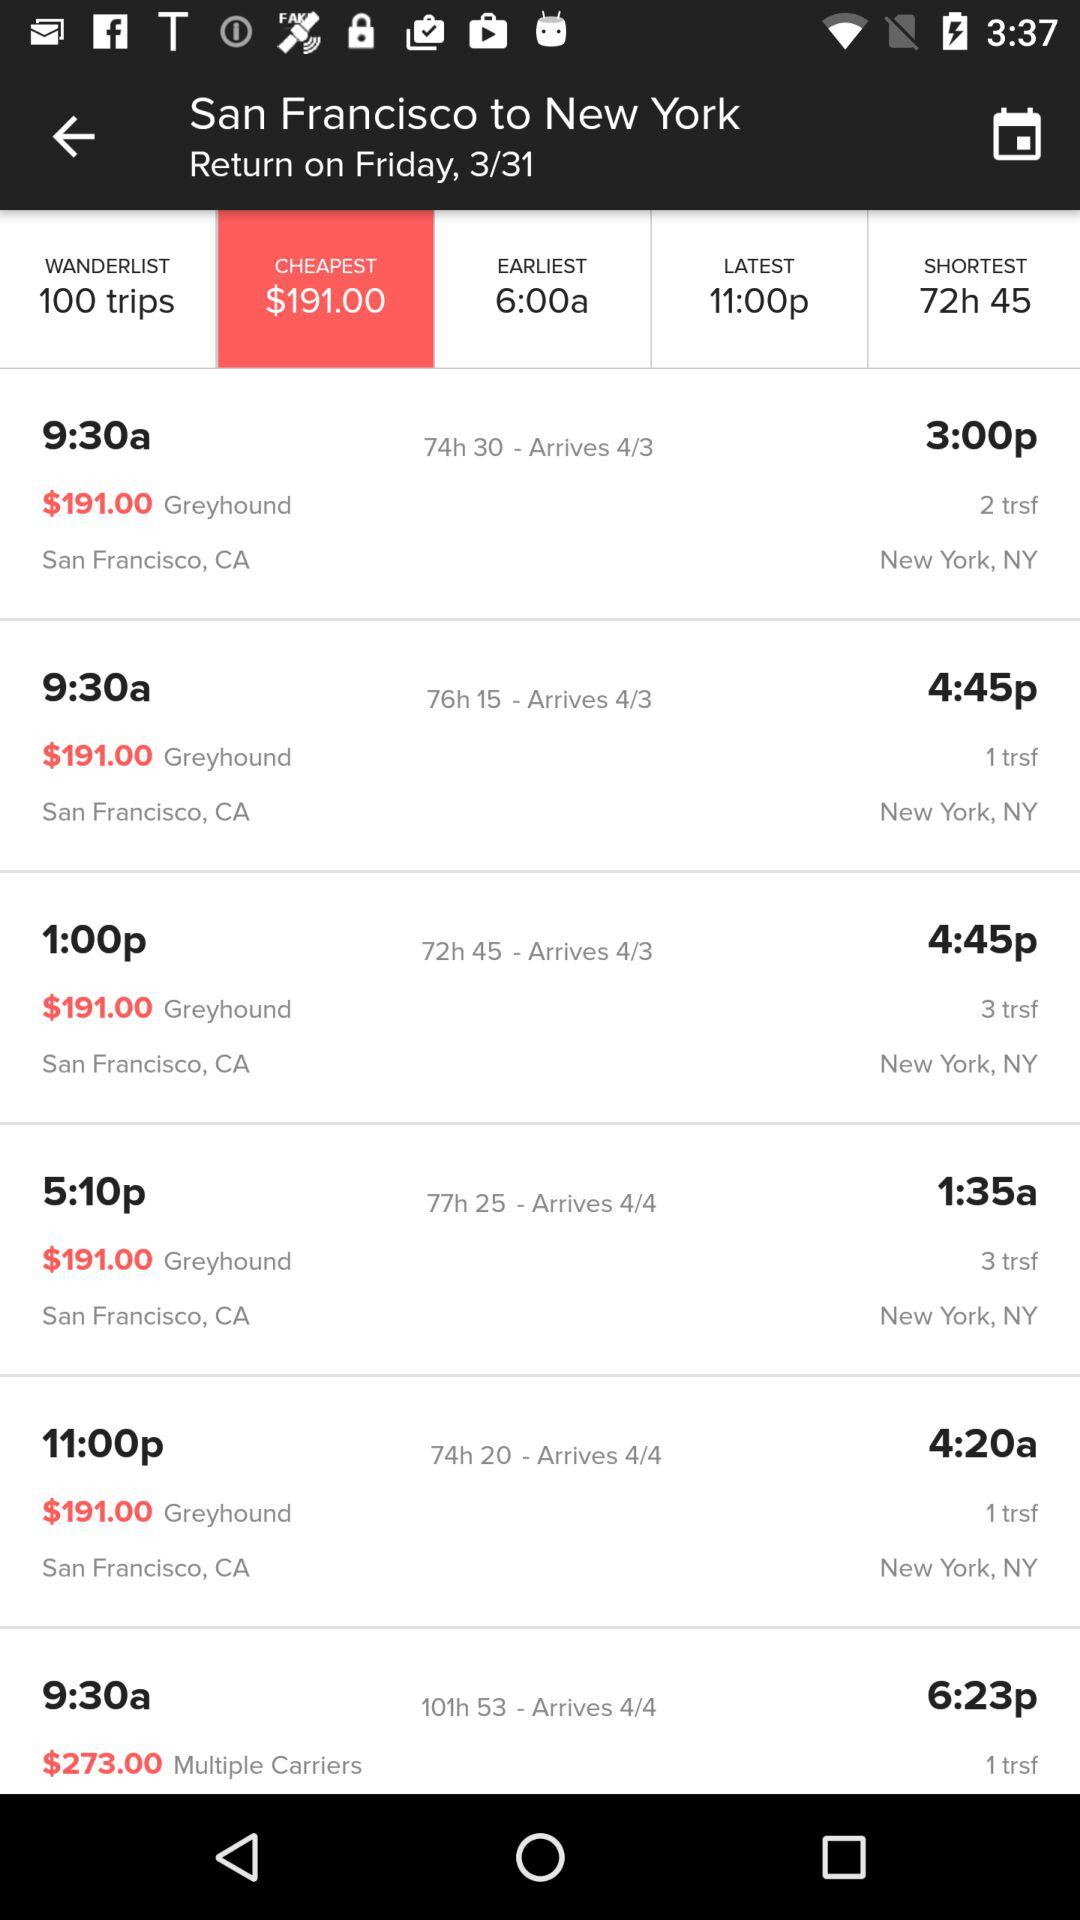Which Cheapest price is selected? The selected price is $191. 